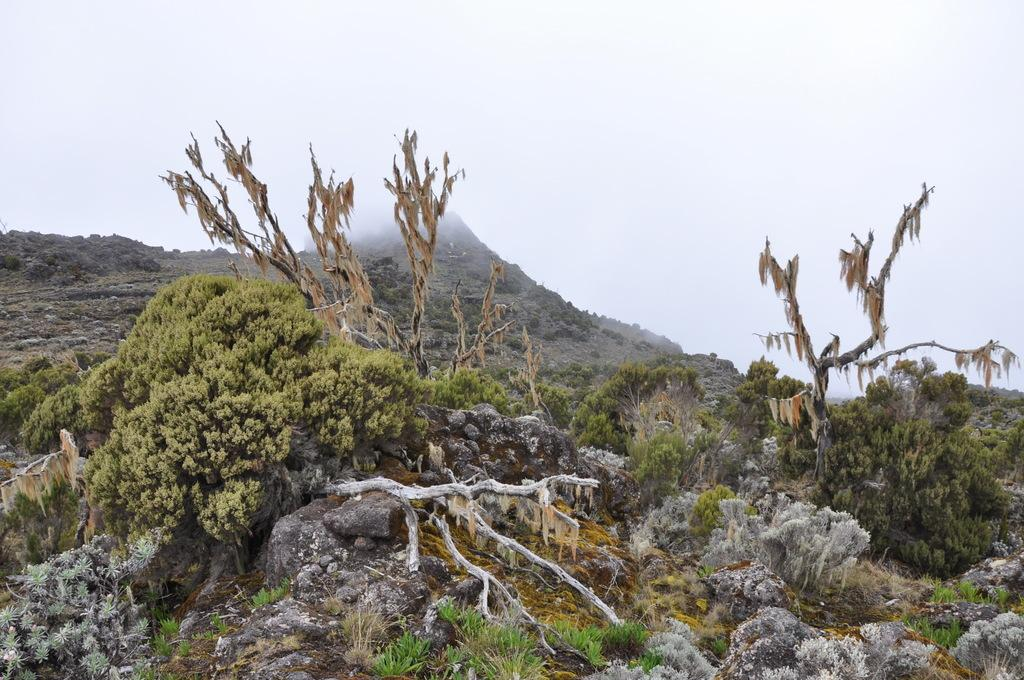What is located in the center of the image? There are stones in the center of the image. What type of vegetation can be seen in the image? There are trees, plants, and grass visible in the image. What is visible in the background of the image? There is sky, clouds, and a hill visible in the background of the image. What type of line can be seen on the bread in the image? There is no bread present in the image, so there is no line on any bread. 